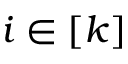<formula> <loc_0><loc_0><loc_500><loc_500>i \in \left [ k \right ]</formula> 